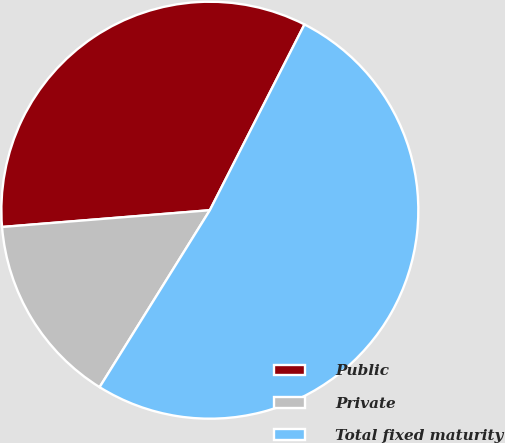Convert chart to OTSL. <chart><loc_0><loc_0><loc_500><loc_500><pie_chart><fcel>Public<fcel>Private<fcel>Total fixed maturity<nl><fcel>33.78%<fcel>14.85%<fcel>51.37%<nl></chart> 